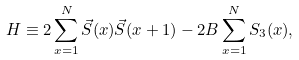<formula> <loc_0><loc_0><loc_500><loc_500>H \equiv 2 \sum _ { x = 1 } ^ { N } \vec { S } ( x ) \vec { S } ( x + 1 ) - 2 B \sum _ { x = 1 } ^ { N } S _ { 3 } ( x ) ,</formula> 